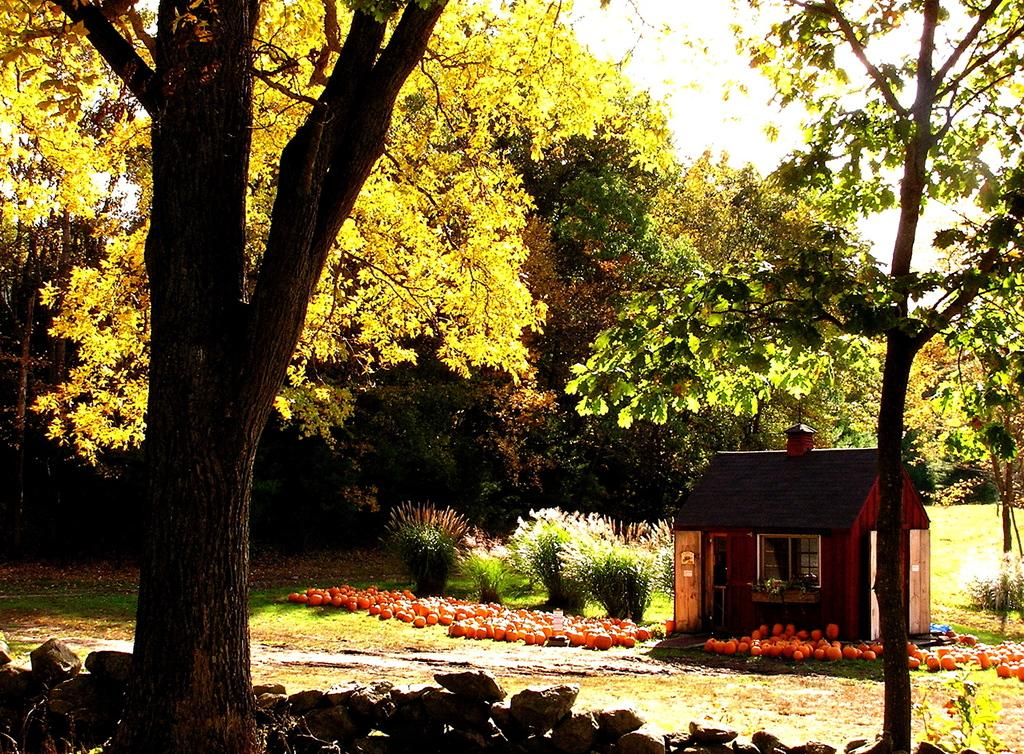What type of structure is visible in the image? There is a small house in the image. What color are the objects that can be seen in the image? There are orange-colored objects in the image. What type of vegetation is present in the image? There is green grass, plants, and trees in the image. What type of material is present in the image? There are stones in the image. What type of knowledge is being shared in the image? There is no indication of knowledge being shared in the image; it primarily features a small house, orange-colored objects, green grass, plants, trees, and stones. 